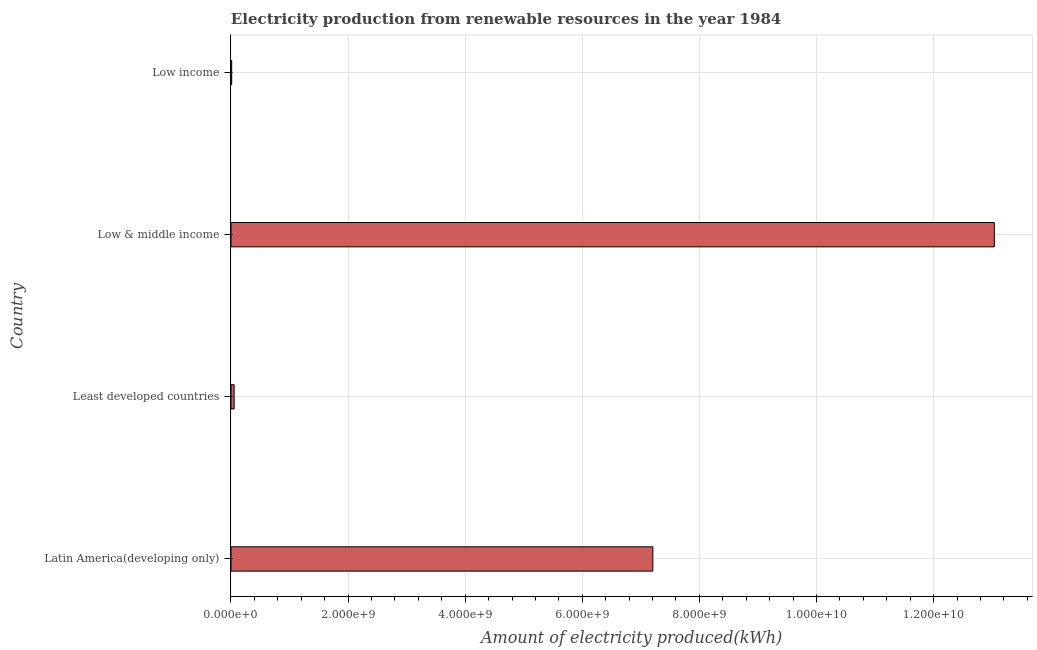Does the graph contain grids?
Give a very brief answer. Yes. What is the title of the graph?
Give a very brief answer. Electricity production from renewable resources in the year 1984. What is the label or title of the X-axis?
Offer a very short reply. Amount of electricity produced(kWh). What is the label or title of the Y-axis?
Offer a very short reply. Country. What is the amount of electricity produced in Low income?
Keep it short and to the point. 1.20e+07. Across all countries, what is the maximum amount of electricity produced?
Provide a short and direct response. 1.30e+1. Across all countries, what is the minimum amount of electricity produced?
Your answer should be very brief. 1.20e+07. In which country was the amount of electricity produced maximum?
Give a very brief answer. Low & middle income. What is the sum of the amount of electricity produced?
Ensure brevity in your answer.  2.03e+1. What is the difference between the amount of electricity produced in Least developed countries and Low & middle income?
Your answer should be compact. -1.30e+1. What is the average amount of electricity produced per country?
Offer a terse response. 5.08e+09. What is the median amount of electricity produced?
Keep it short and to the point. 3.63e+09. Is the difference between the amount of electricity produced in Low & middle income and Low income greater than the difference between any two countries?
Your answer should be very brief. Yes. What is the difference between the highest and the second highest amount of electricity produced?
Keep it short and to the point. 5.83e+09. What is the difference between the highest and the lowest amount of electricity produced?
Your answer should be compact. 1.30e+1. How many countries are there in the graph?
Ensure brevity in your answer.  4. What is the difference between two consecutive major ticks on the X-axis?
Your answer should be compact. 2.00e+09. What is the Amount of electricity produced(kWh) in Latin America(developing only)?
Ensure brevity in your answer.  7.20e+09. What is the Amount of electricity produced(kWh) in Least developed countries?
Give a very brief answer. 5.40e+07. What is the Amount of electricity produced(kWh) in Low & middle income?
Keep it short and to the point. 1.30e+1. What is the difference between the Amount of electricity produced(kWh) in Latin America(developing only) and Least developed countries?
Provide a succinct answer. 7.15e+09. What is the difference between the Amount of electricity produced(kWh) in Latin America(developing only) and Low & middle income?
Your response must be concise. -5.83e+09. What is the difference between the Amount of electricity produced(kWh) in Latin America(developing only) and Low income?
Provide a short and direct response. 7.19e+09. What is the difference between the Amount of electricity produced(kWh) in Least developed countries and Low & middle income?
Offer a very short reply. -1.30e+1. What is the difference between the Amount of electricity produced(kWh) in Least developed countries and Low income?
Offer a terse response. 4.20e+07. What is the difference between the Amount of electricity produced(kWh) in Low & middle income and Low income?
Give a very brief answer. 1.30e+1. What is the ratio of the Amount of electricity produced(kWh) in Latin America(developing only) to that in Least developed countries?
Keep it short and to the point. 133.43. What is the ratio of the Amount of electricity produced(kWh) in Latin America(developing only) to that in Low & middle income?
Your answer should be very brief. 0.55. What is the ratio of the Amount of electricity produced(kWh) in Latin America(developing only) to that in Low income?
Your answer should be compact. 600.42. What is the ratio of the Amount of electricity produced(kWh) in Least developed countries to that in Low & middle income?
Give a very brief answer. 0. What is the ratio of the Amount of electricity produced(kWh) in Least developed countries to that in Low income?
Your response must be concise. 4.5. What is the ratio of the Amount of electricity produced(kWh) in Low & middle income to that in Low income?
Ensure brevity in your answer.  1086.42. 